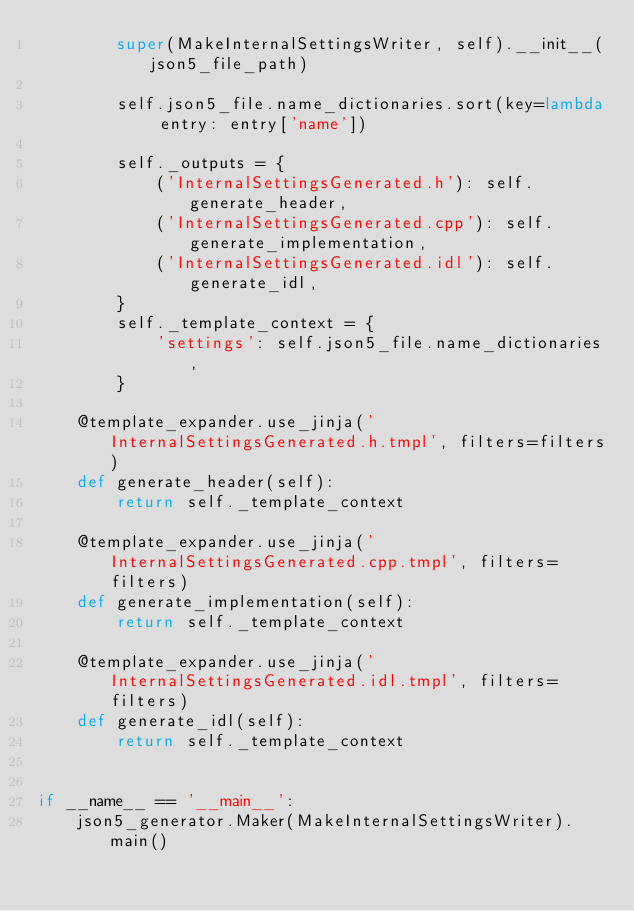Convert code to text. <code><loc_0><loc_0><loc_500><loc_500><_Python_>        super(MakeInternalSettingsWriter, self).__init__(json5_file_path)

        self.json5_file.name_dictionaries.sort(key=lambda entry: entry['name'])

        self._outputs = {
            ('InternalSettingsGenerated.h'): self.generate_header,
            ('InternalSettingsGenerated.cpp'): self.generate_implementation,
            ('InternalSettingsGenerated.idl'): self.generate_idl,
        }
        self._template_context = {
            'settings': self.json5_file.name_dictionaries,
        }

    @template_expander.use_jinja('InternalSettingsGenerated.h.tmpl', filters=filters)
    def generate_header(self):
        return self._template_context

    @template_expander.use_jinja('InternalSettingsGenerated.cpp.tmpl', filters=filters)
    def generate_implementation(self):
        return self._template_context

    @template_expander.use_jinja('InternalSettingsGenerated.idl.tmpl', filters=filters)
    def generate_idl(self):
        return self._template_context


if __name__ == '__main__':
    json5_generator.Maker(MakeInternalSettingsWriter).main()
</code> 